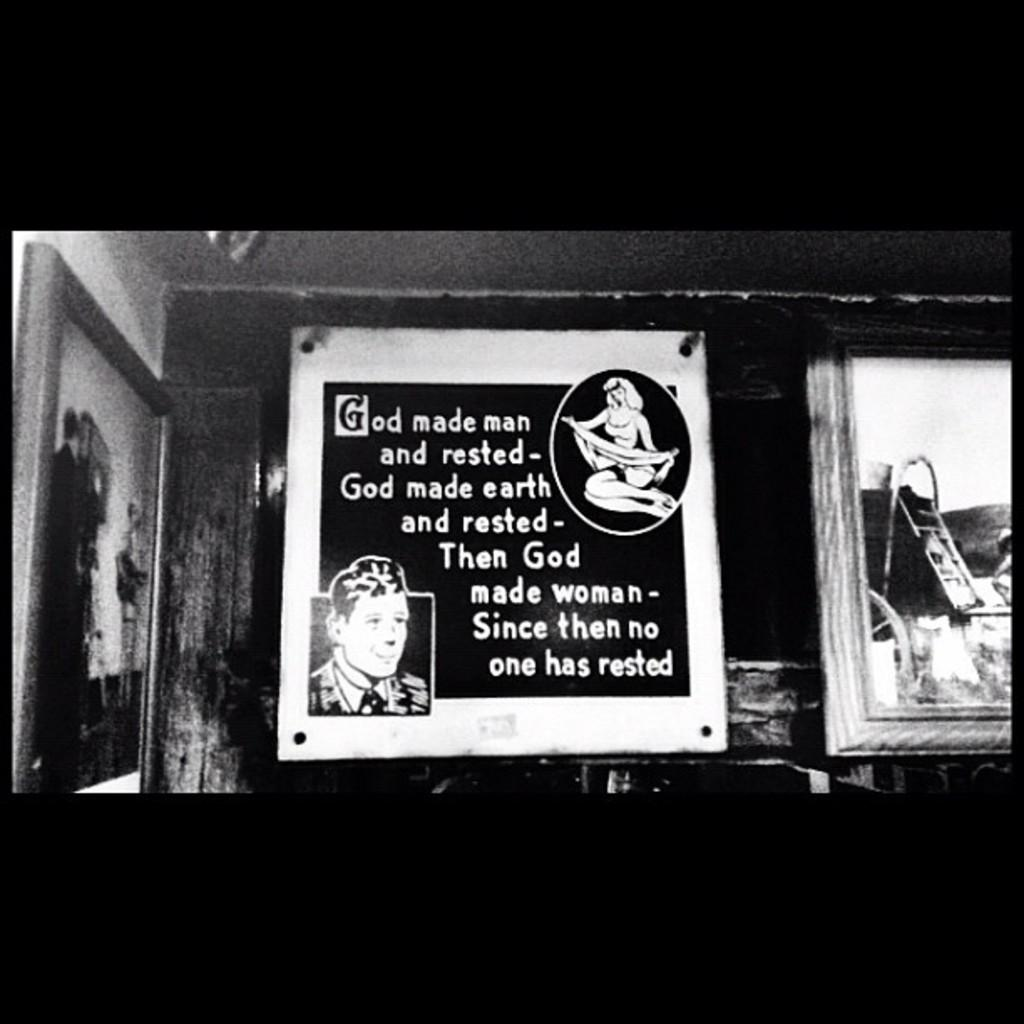<image>
Relay a brief, clear account of the picture shown. Poster on a wall that says that "God made man and rested". 